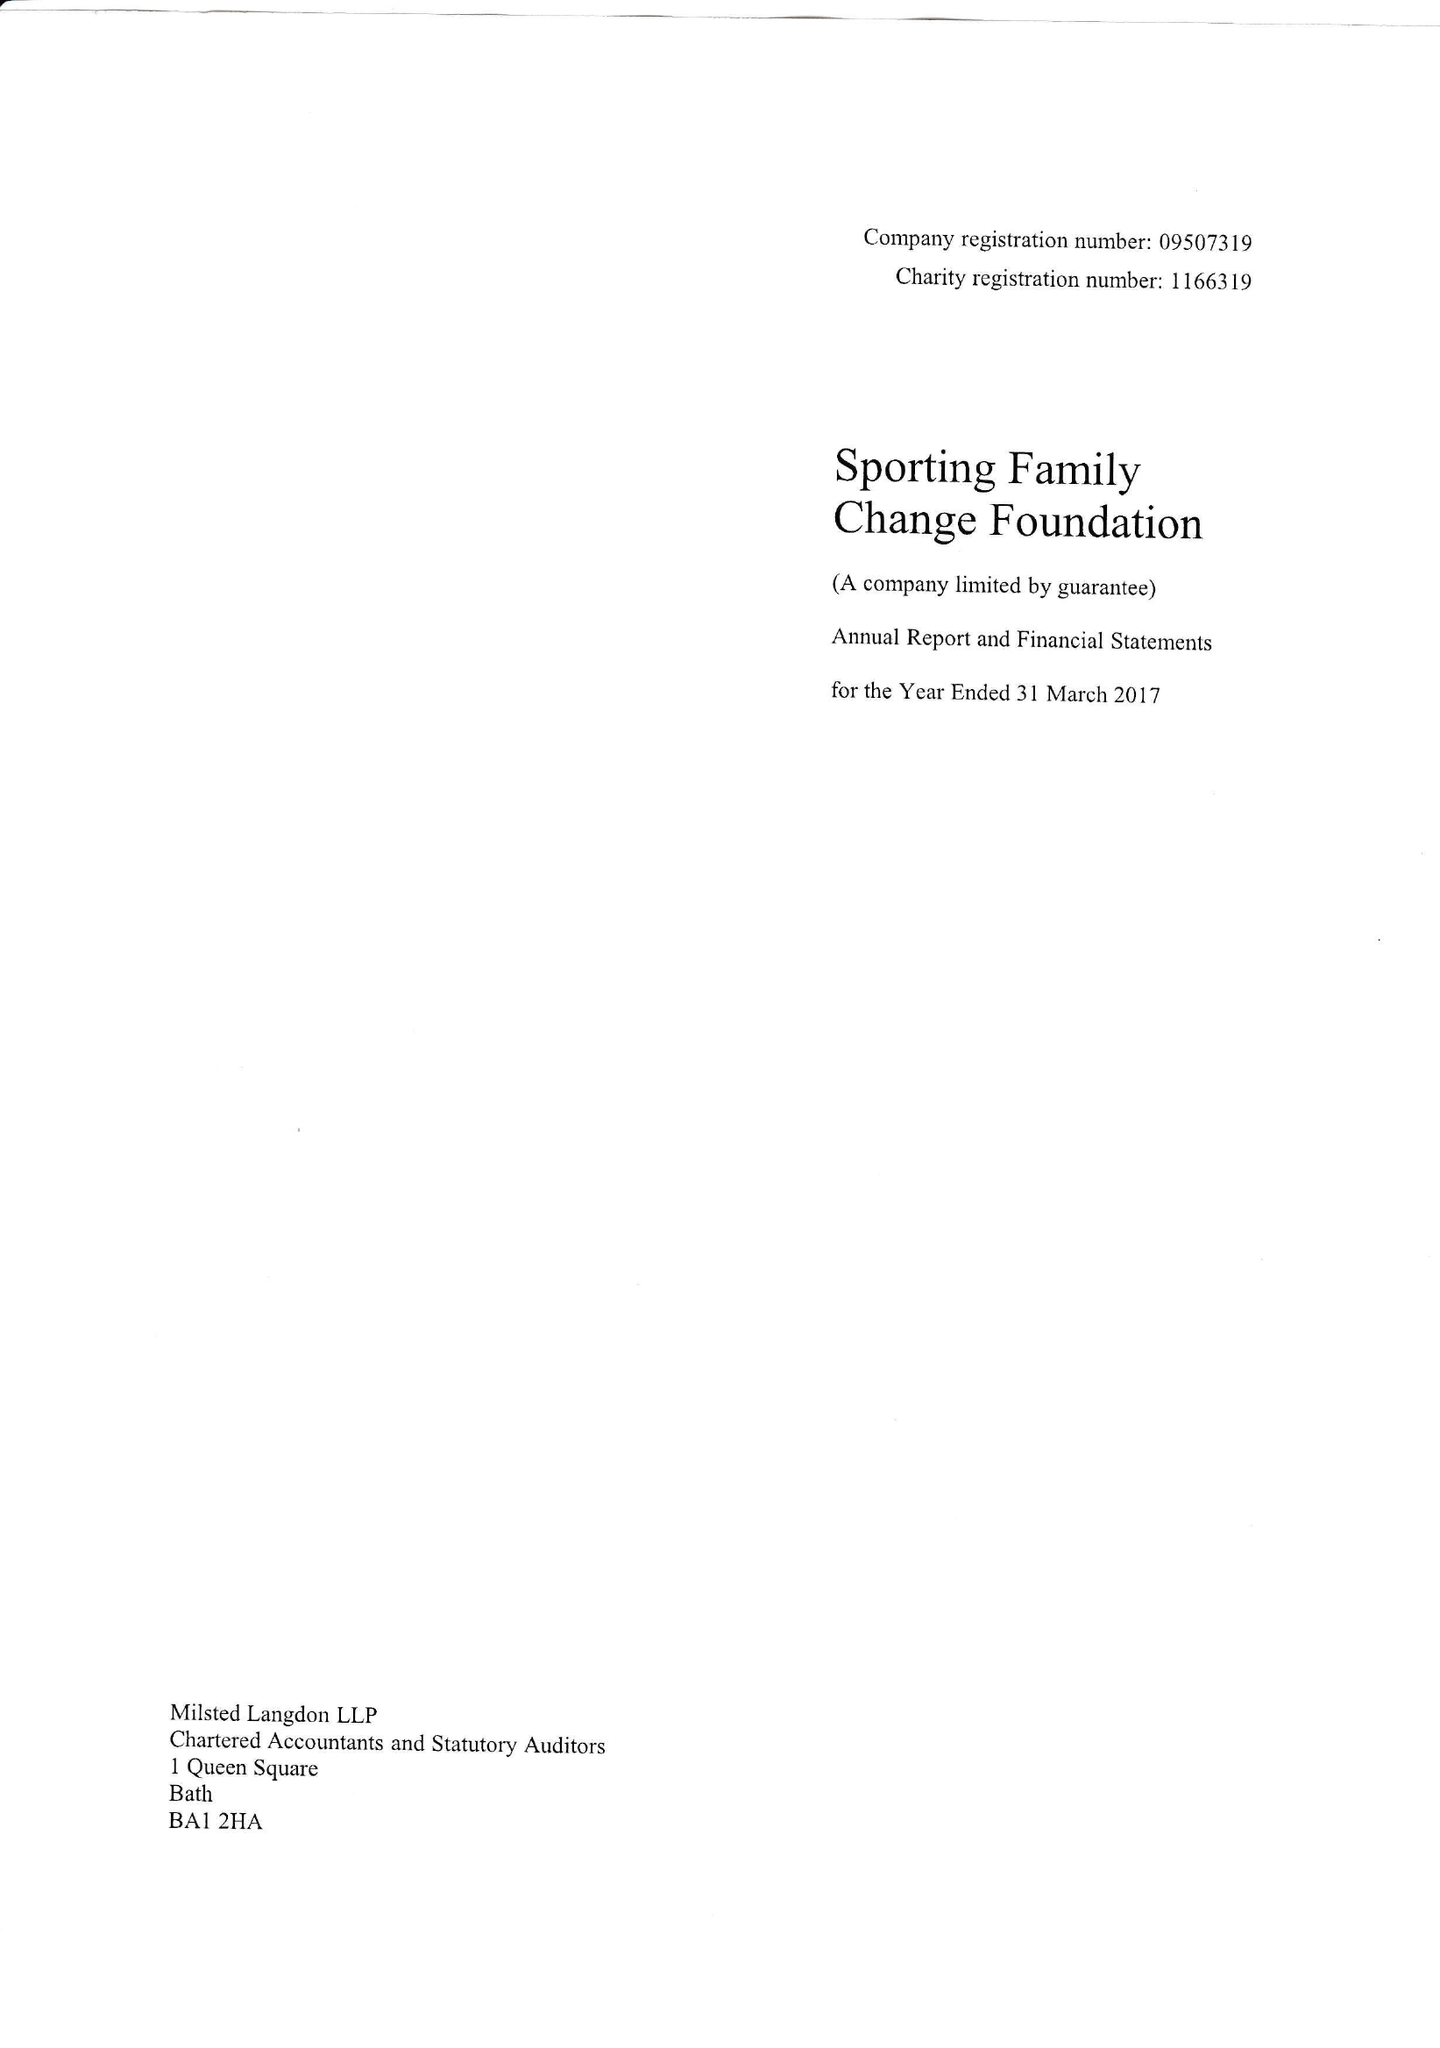What is the value for the charity_name?
Answer the question using a single word or phrase. Sporting Family Change Foundation 